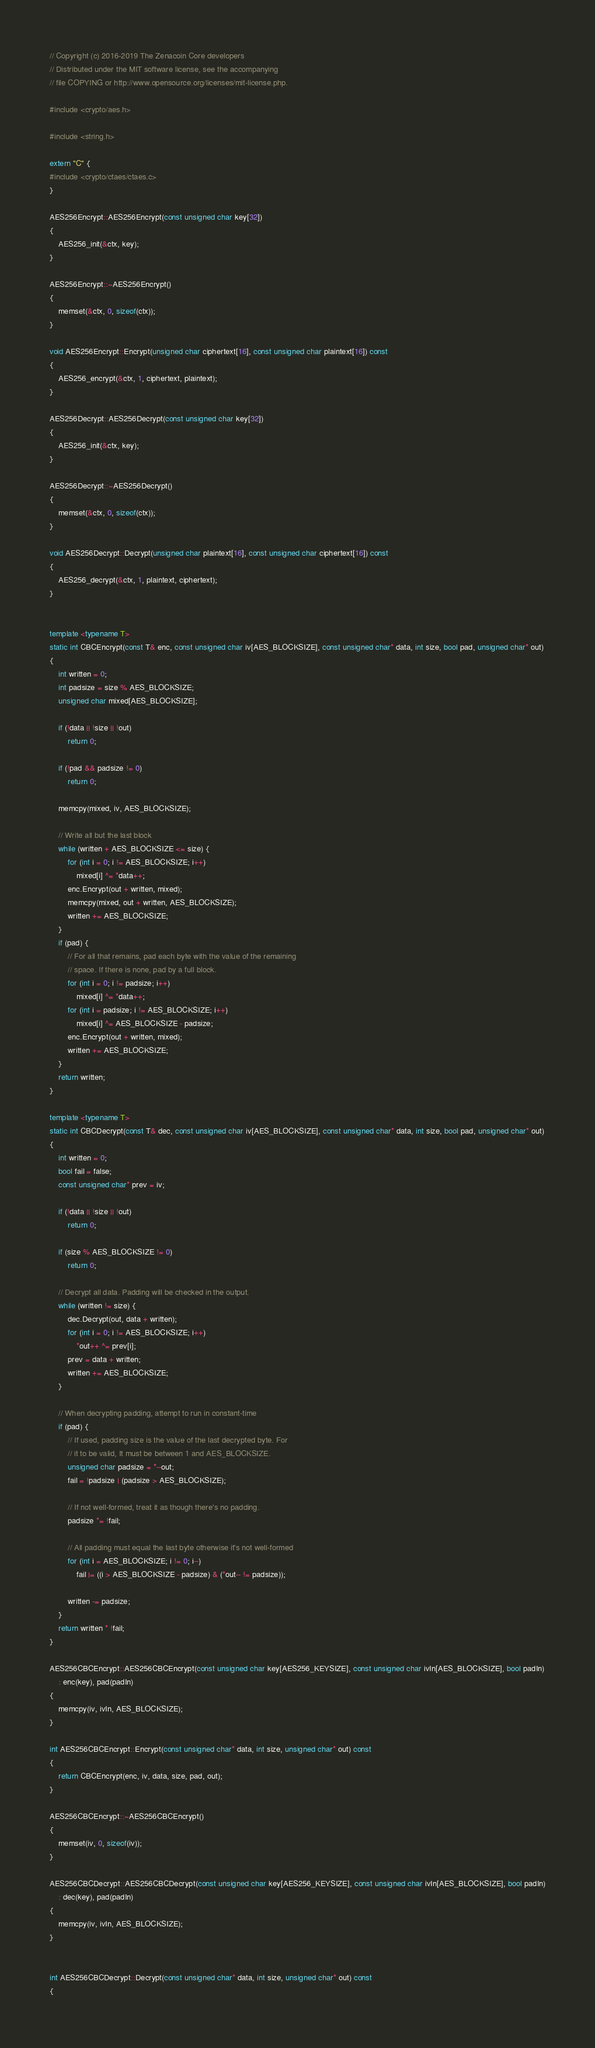<code> <loc_0><loc_0><loc_500><loc_500><_C++_>// Copyright (c) 2016-2019 The Zenacoin Core developers
// Distributed under the MIT software license, see the accompanying
// file COPYING or http://www.opensource.org/licenses/mit-license.php.

#include <crypto/aes.h>

#include <string.h>

extern "C" {
#include <crypto/ctaes/ctaes.c>
}

AES256Encrypt::AES256Encrypt(const unsigned char key[32])
{
    AES256_init(&ctx, key);
}

AES256Encrypt::~AES256Encrypt()
{
    memset(&ctx, 0, sizeof(ctx));
}

void AES256Encrypt::Encrypt(unsigned char ciphertext[16], const unsigned char plaintext[16]) const
{
    AES256_encrypt(&ctx, 1, ciphertext, plaintext);
}

AES256Decrypt::AES256Decrypt(const unsigned char key[32])
{
    AES256_init(&ctx, key);
}

AES256Decrypt::~AES256Decrypt()
{
    memset(&ctx, 0, sizeof(ctx));
}

void AES256Decrypt::Decrypt(unsigned char plaintext[16], const unsigned char ciphertext[16]) const
{
    AES256_decrypt(&ctx, 1, plaintext, ciphertext);
}


template <typename T>
static int CBCEncrypt(const T& enc, const unsigned char iv[AES_BLOCKSIZE], const unsigned char* data, int size, bool pad, unsigned char* out)
{
    int written = 0;
    int padsize = size % AES_BLOCKSIZE;
    unsigned char mixed[AES_BLOCKSIZE];

    if (!data || !size || !out)
        return 0;

    if (!pad && padsize != 0)
        return 0;

    memcpy(mixed, iv, AES_BLOCKSIZE);

    // Write all but the last block
    while (written + AES_BLOCKSIZE <= size) {
        for (int i = 0; i != AES_BLOCKSIZE; i++)
            mixed[i] ^= *data++;
        enc.Encrypt(out + written, mixed);
        memcpy(mixed, out + written, AES_BLOCKSIZE);
        written += AES_BLOCKSIZE;
    }
    if (pad) {
        // For all that remains, pad each byte with the value of the remaining
        // space. If there is none, pad by a full block.
        for (int i = 0; i != padsize; i++)
            mixed[i] ^= *data++;
        for (int i = padsize; i != AES_BLOCKSIZE; i++)
            mixed[i] ^= AES_BLOCKSIZE - padsize;
        enc.Encrypt(out + written, mixed);
        written += AES_BLOCKSIZE;
    }
    return written;
}

template <typename T>
static int CBCDecrypt(const T& dec, const unsigned char iv[AES_BLOCKSIZE], const unsigned char* data, int size, bool pad, unsigned char* out)
{
    int written = 0;
    bool fail = false;
    const unsigned char* prev = iv;

    if (!data || !size || !out)
        return 0;

    if (size % AES_BLOCKSIZE != 0)
        return 0;

    // Decrypt all data. Padding will be checked in the output.
    while (written != size) {
        dec.Decrypt(out, data + written);
        for (int i = 0; i != AES_BLOCKSIZE; i++)
            *out++ ^= prev[i];
        prev = data + written;
        written += AES_BLOCKSIZE;
    }

    // When decrypting padding, attempt to run in constant-time
    if (pad) {
        // If used, padding size is the value of the last decrypted byte. For
        // it to be valid, It must be between 1 and AES_BLOCKSIZE.
        unsigned char padsize = *--out;
        fail = !padsize | (padsize > AES_BLOCKSIZE);

        // If not well-formed, treat it as though there's no padding.
        padsize *= !fail;

        // All padding must equal the last byte otherwise it's not well-formed
        for (int i = AES_BLOCKSIZE; i != 0; i--)
            fail |= ((i > AES_BLOCKSIZE - padsize) & (*out-- != padsize));

        written -= padsize;
    }
    return written * !fail;
}

AES256CBCEncrypt::AES256CBCEncrypt(const unsigned char key[AES256_KEYSIZE], const unsigned char ivIn[AES_BLOCKSIZE], bool padIn)
    : enc(key), pad(padIn)
{
    memcpy(iv, ivIn, AES_BLOCKSIZE);
}

int AES256CBCEncrypt::Encrypt(const unsigned char* data, int size, unsigned char* out) const
{
    return CBCEncrypt(enc, iv, data, size, pad, out);
}

AES256CBCEncrypt::~AES256CBCEncrypt()
{
    memset(iv, 0, sizeof(iv));
}

AES256CBCDecrypt::AES256CBCDecrypt(const unsigned char key[AES256_KEYSIZE], const unsigned char ivIn[AES_BLOCKSIZE], bool padIn)
    : dec(key), pad(padIn)
{
    memcpy(iv, ivIn, AES_BLOCKSIZE);
}


int AES256CBCDecrypt::Decrypt(const unsigned char* data, int size, unsigned char* out) const
{</code> 